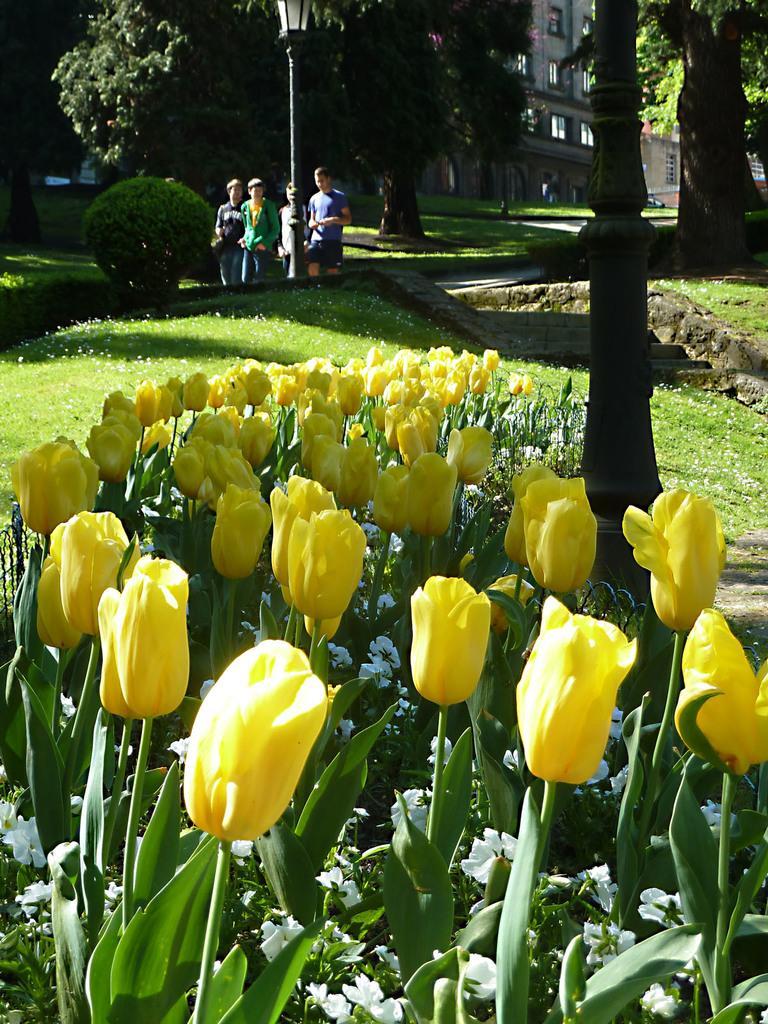In one or two sentences, can you explain what this image depicts? In this image I can see number of yellow colour flowers in the front. In the background and see few poles, a light, a plant, shadows on ground, few trees, a building and few people are standing. 